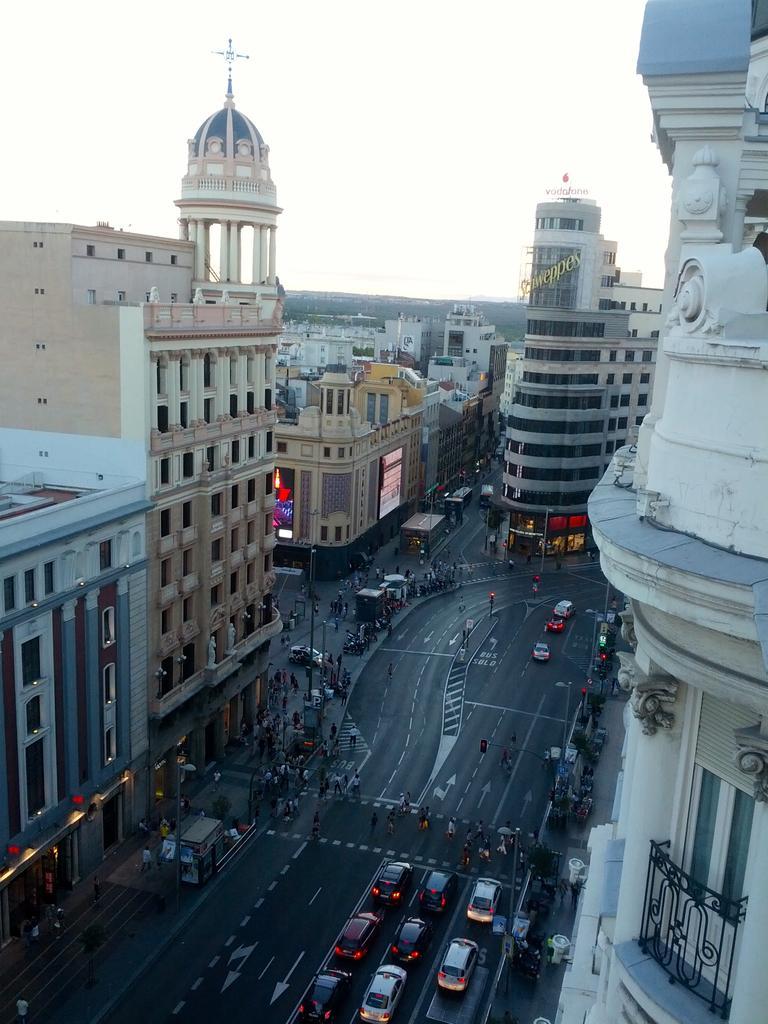Can you describe this image briefly? In this image we can see vehicles on the road. Here we can see buildings, poles, boards, and people. In the background there is sky. 